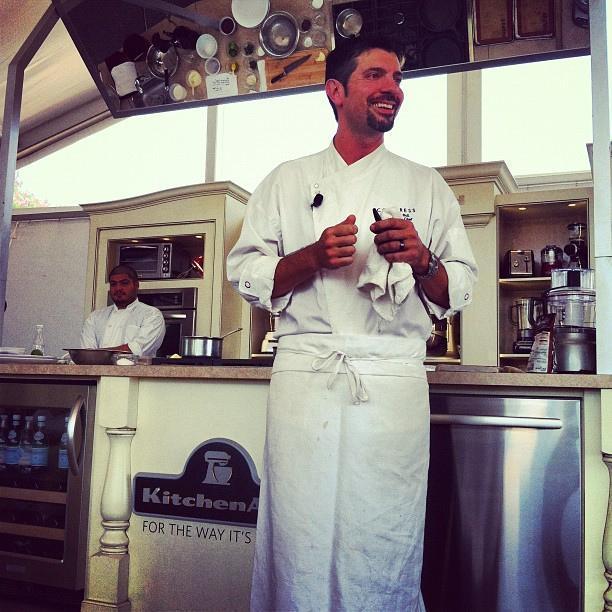Why are the men dressed in white?
Select the correct answer and articulate reasoning with the following format: 'Answer: answer
Rationale: rationale.'
Options: Dress code, personal preference, fashion, visibility. Answer: dress code.
Rationale: This is his work uniform. he works in a kitchen as a chef. 